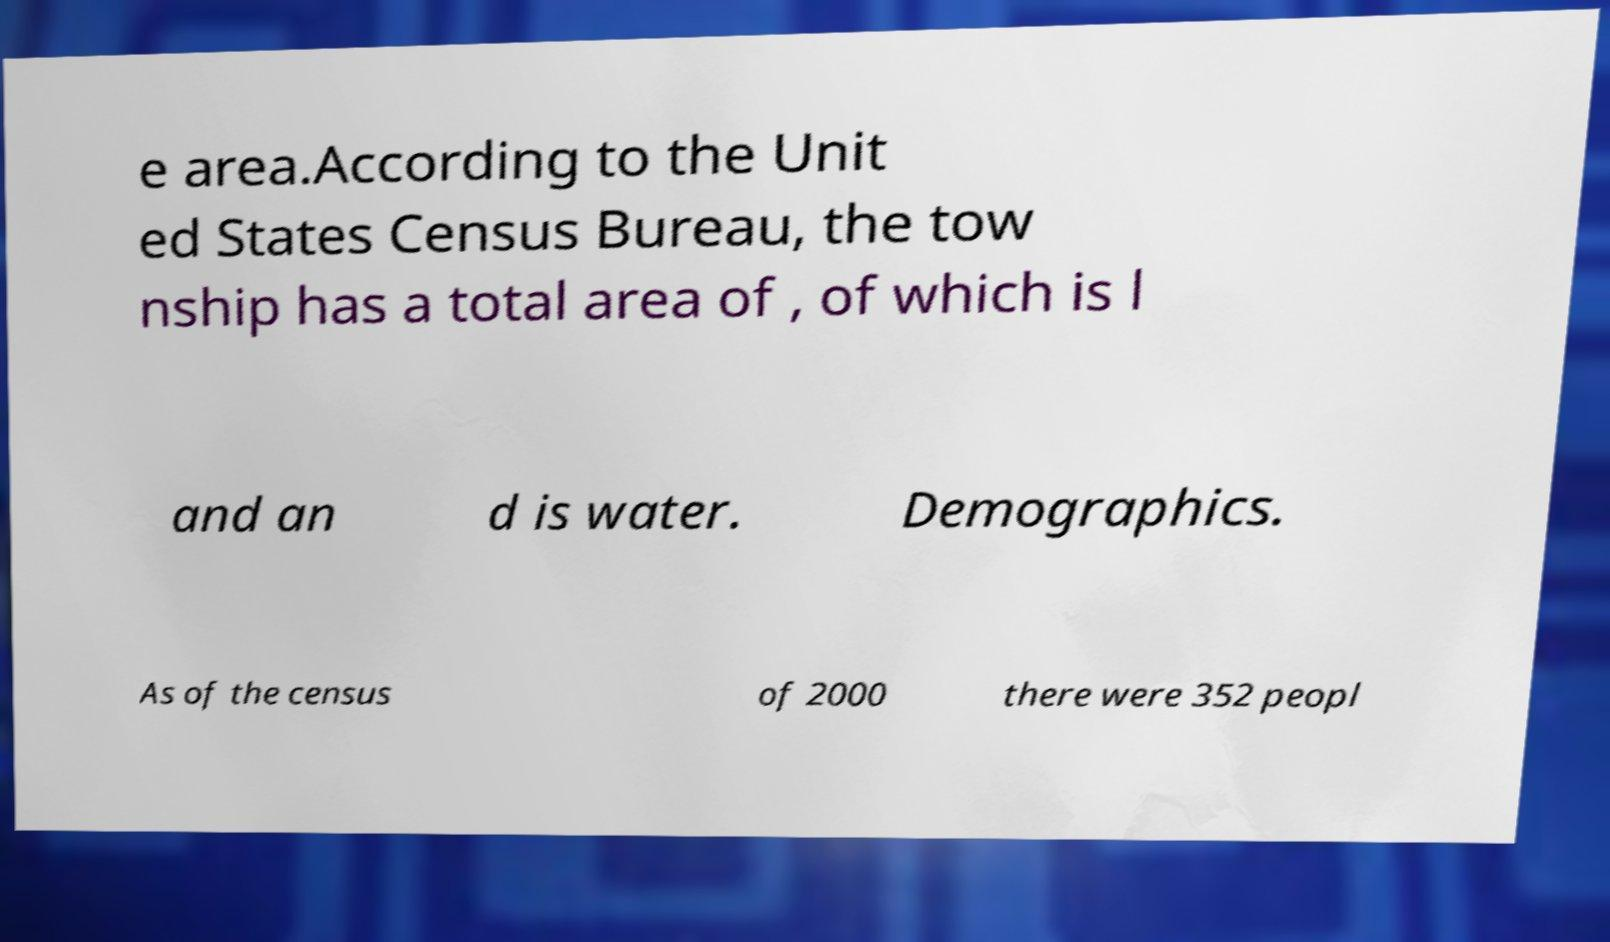Could you assist in decoding the text presented in this image and type it out clearly? e area.According to the Unit ed States Census Bureau, the tow nship has a total area of , of which is l and an d is water. Demographics. As of the census of 2000 there were 352 peopl 